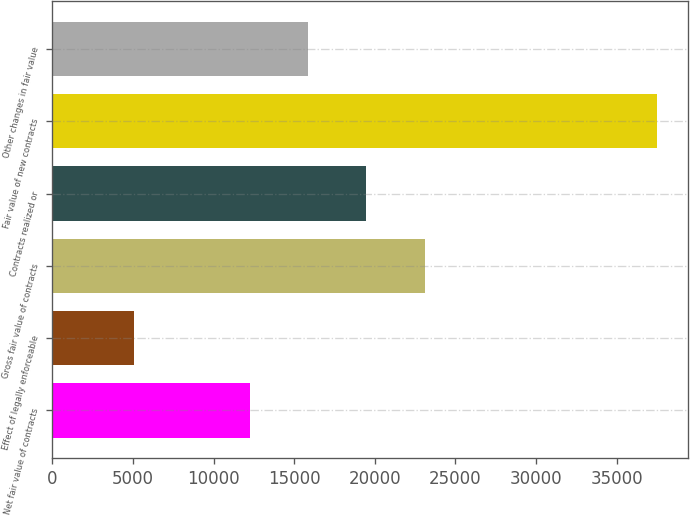Convert chart to OTSL. <chart><loc_0><loc_0><loc_500><loc_500><bar_chart><fcel>Net fair value of contracts<fcel>Effect of legally enforceable<fcel>Gross fair value of contracts<fcel>Contracts realized or<fcel>Fair value of new contracts<fcel>Other changes in fair value<nl><fcel>12269.7<fcel>5055.9<fcel>23090.4<fcel>19483.5<fcel>37518<fcel>15876.6<nl></chart> 